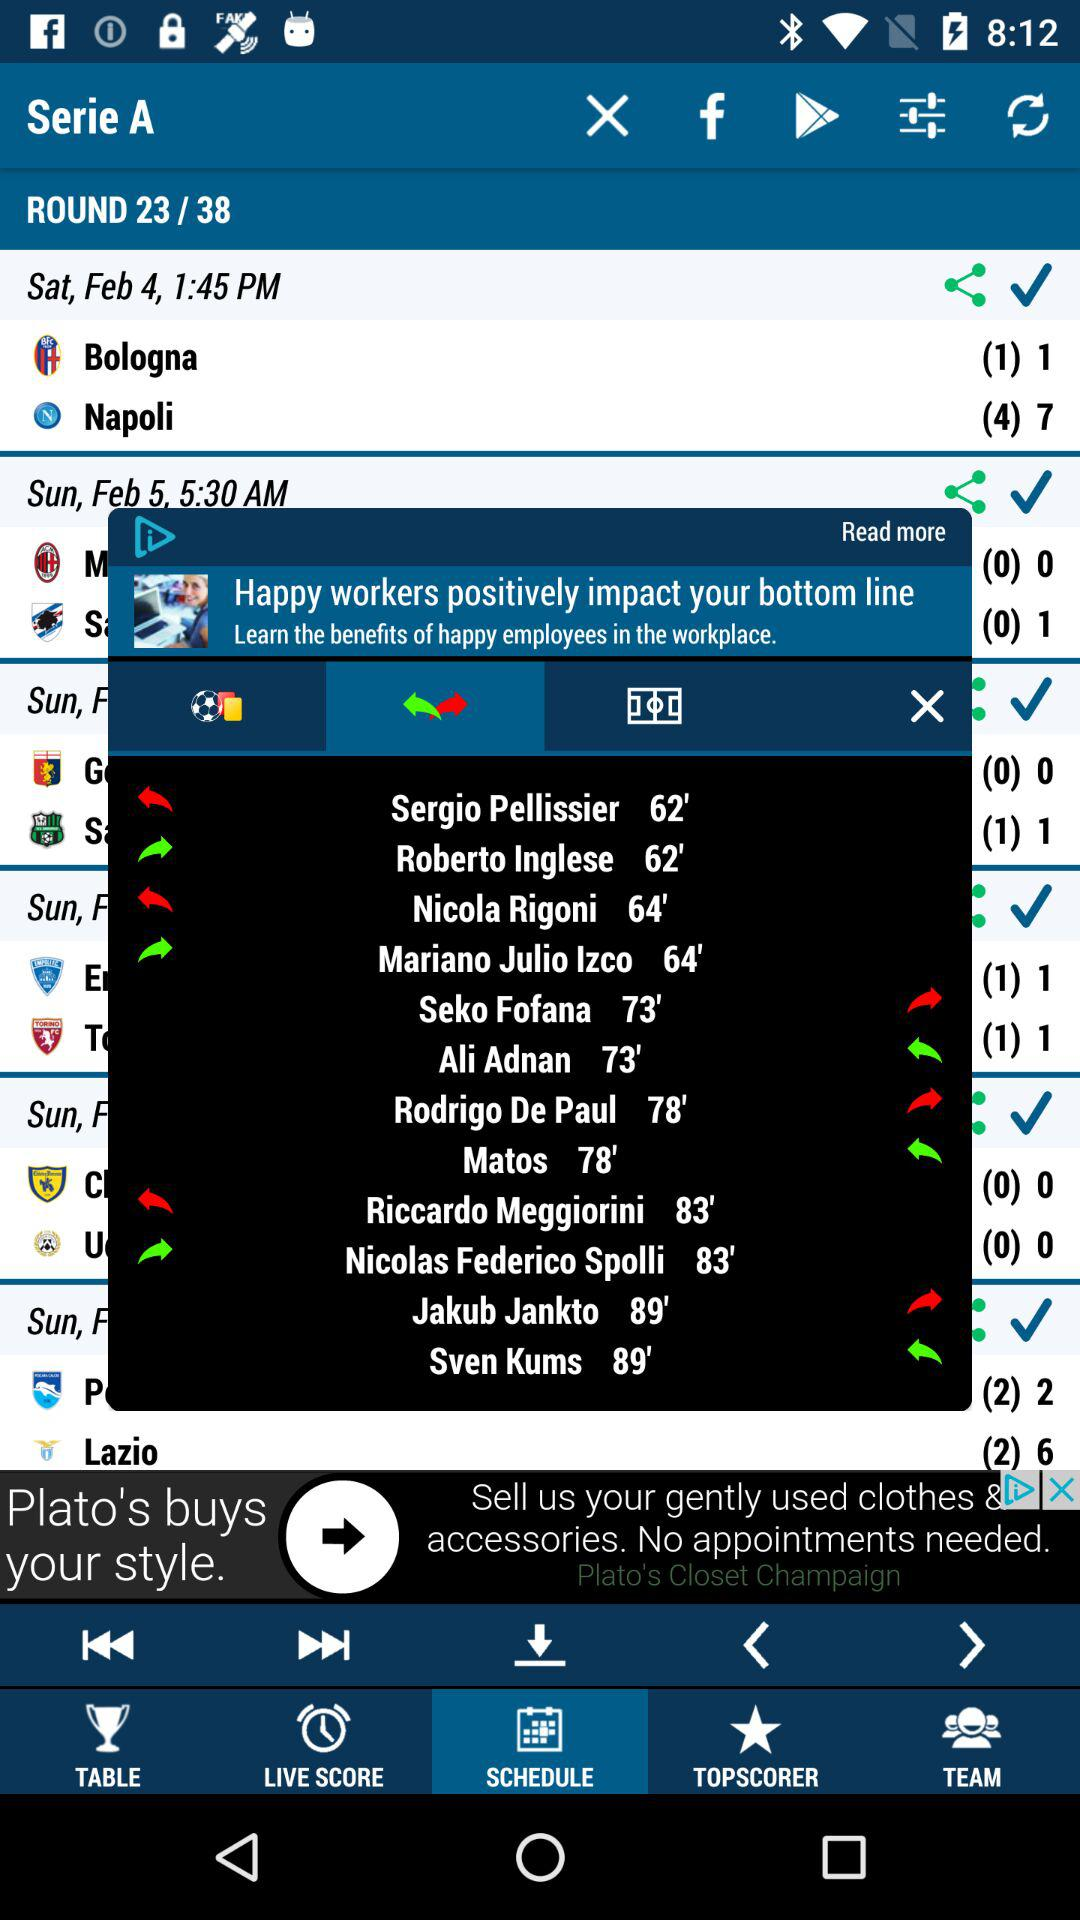What is the total number of rounds? The total number of rounds is 38. 